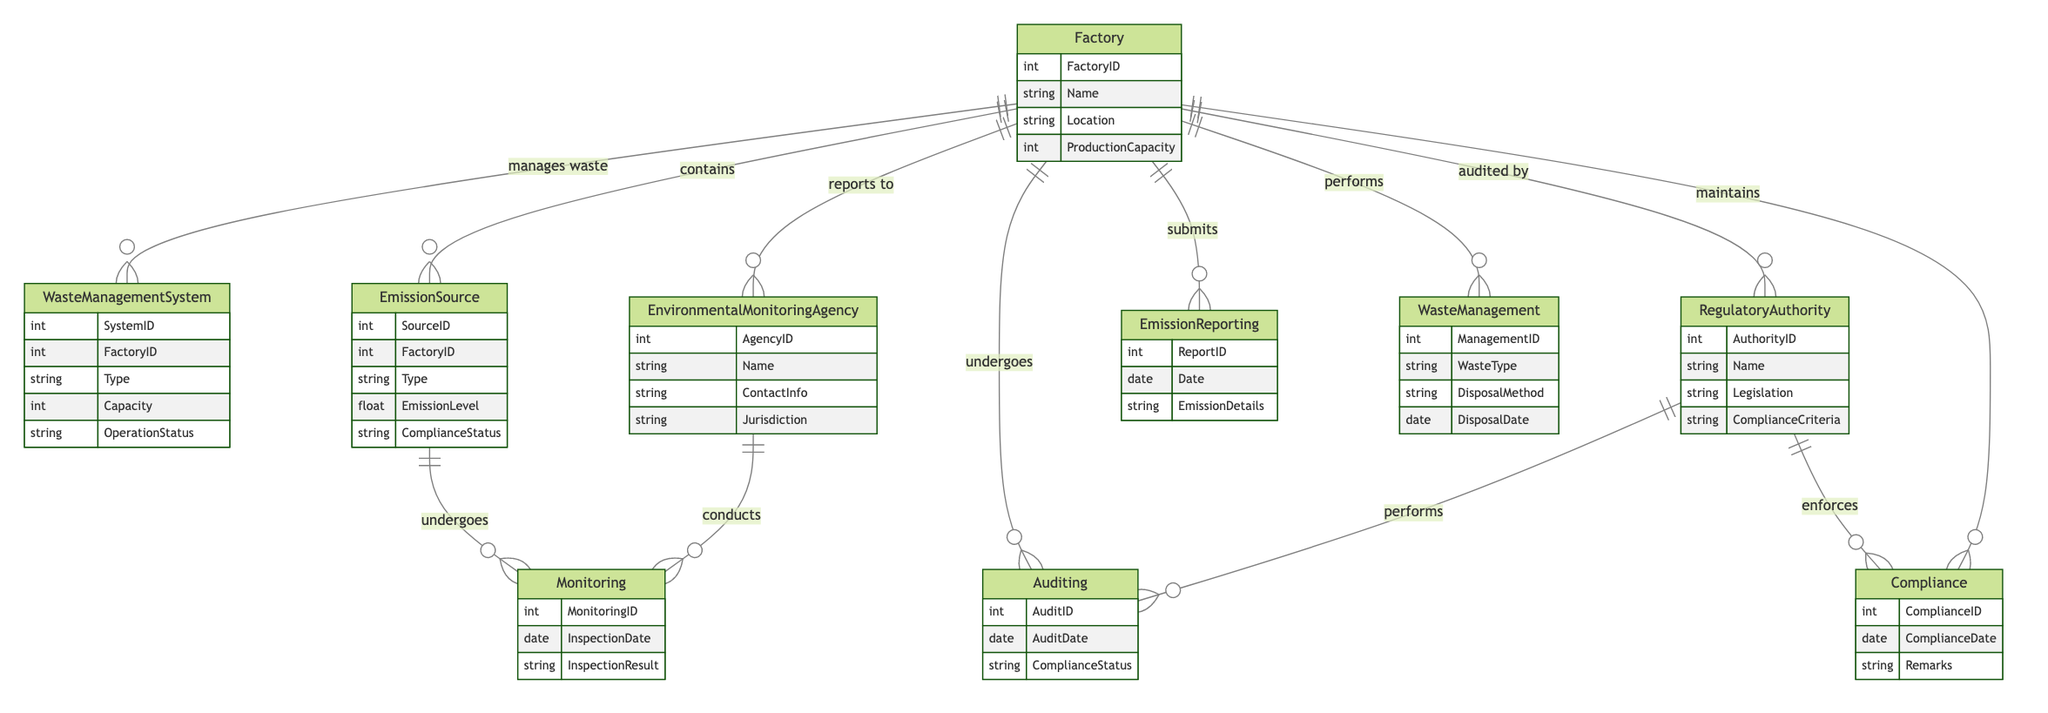What entities are involved in Emission Reporting? The entities involved in Emission Reporting as per the diagram are Factory and Environmental Monitoring Agency. This can be identified by tracing the relationship labeled "submits," which connects the Factory to the EmissionReporting node, showing that factories report emissions to the monitoring agencies.
Answer: Factory, Environmental Monitoring Agency How many entities are there in total? By counting each unique entity listed in the diagram, we find Factory, Waste Management System, Emission Source, Environmental Monitoring Agency, and Regulatory Authority, totaling five entities altogether.
Answer: Five What is the Compliance ID attribute used for? The Compliance ID attribute is used within the Compliance relationship, which allows the diagram to track the compliance status of factories concerning regulatory authorities. This helps in indicating whether a factory is meeting necessary environmental regulations.
Answer: Compliance status tracking Which entity conducts the Monitoring? The entity that conducts the Monitoring is the Environmental Monitoring Agency. This is evident from the relationship labeled "conducts," connecting the Environmental Monitoring Agency to the Monitoring entity, which includes attributes related to inspections.
Answer: Environmental Monitoring Agency What relationship connects Factory and Regulatory Authority? The relationship that connects Factory and Regulatory Authority is the Auditing relationship. This is indicated by the label "audited by" on the connecting line between the Factory and the Regulatory Authority.
Answer: Auditing What is the purpose of the Waste Management relationship? The purpose of the Waste Management relationship is to detail how factories manage waste through various disposal methods, as shown in the attributes of the WasteManagement relationship, which include ManagementID, WasteType, DisposalMethod, and DisposalDate.
Answer: Waste management process Which entity has the highest number of attributes? The Factories entity has the highest number of attributes, which include FactoryID, Name, Location, and ProductionCapacity (four attributes total). This indicates a wider range of information about their operations compared to other entities.
Answer: Factory What is the relationship type between Emission Source and Monitoring? The relationship type between Emission Source and Monitoring is that the Emission Source undergoes monitoring. This is specified by the relationship labeled "undergoes," which connects these two entities.
Answer: Undergoes How is compliance determined according to the diagram? Compliance is determined through the Compliance relationship, which links the Factory and Regulatory Authority. This relationship tracks compliance statuses through attributes like ComplianceID, ComplianceDate, and Remarks, indicating if and how factories meet regulatory standards.
Answer: Compliance tracking 